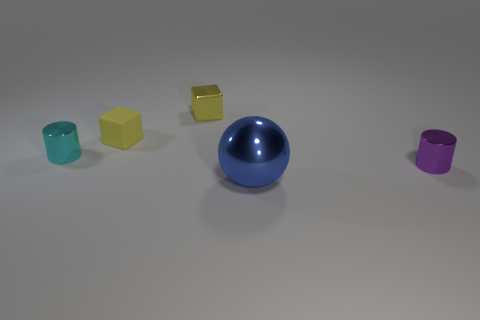Are there any other small matte objects that have the same shape as the blue object?
Your answer should be very brief. No. There is a shiny cylinder that is in front of the cylinder that is behind the cylinder that is to the right of the big thing; what is its color?
Provide a succinct answer. Purple. What number of matte things are cyan objects or tiny yellow objects?
Ensure brevity in your answer.  1. Is the number of yellow metallic objects that are to the right of the big shiny object greater than the number of purple metal cylinders behind the purple metal thing?
Offer a very short reply. No. What number of other things are the same size as the purple object?
Offer a very short reply. 3. What is the size of the cylinder behind the tiny cylinder that is right of the large metal ball?
Offer a very short reply. Small. What number of small things are purple objects or yellow matte things?
Provide a short and direct response. 2. There is a cylinder that is on the left side of the tiny metal thing in front of the thing that is to the left of the tiny yellow rubber object; how big is it?
Offer a terse response. Small. Is there anything else that has the same color as the large metal thing?
Your response must be concise. No. What material is the cylinder that is in front of the cylinder left of the tiny metallic cylinder that is right of the large shiny object?
Make the answer very short. Metal. 